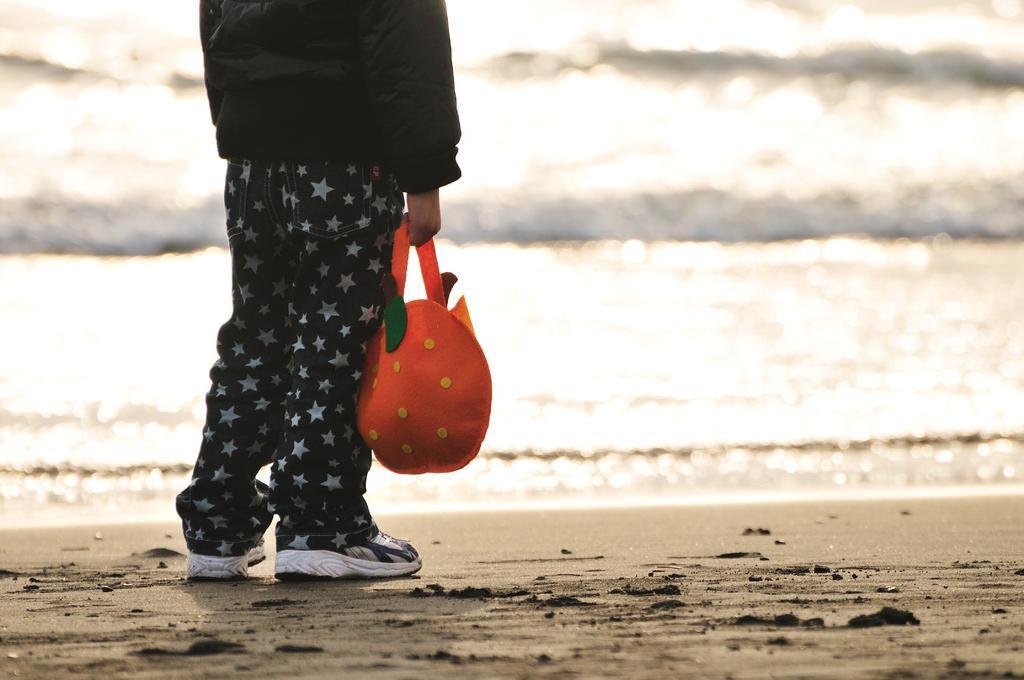Can you describe this image briefly? In this image we can see a person is standing on the land. The person is holding an orange color bag. In the background, we can see water. 